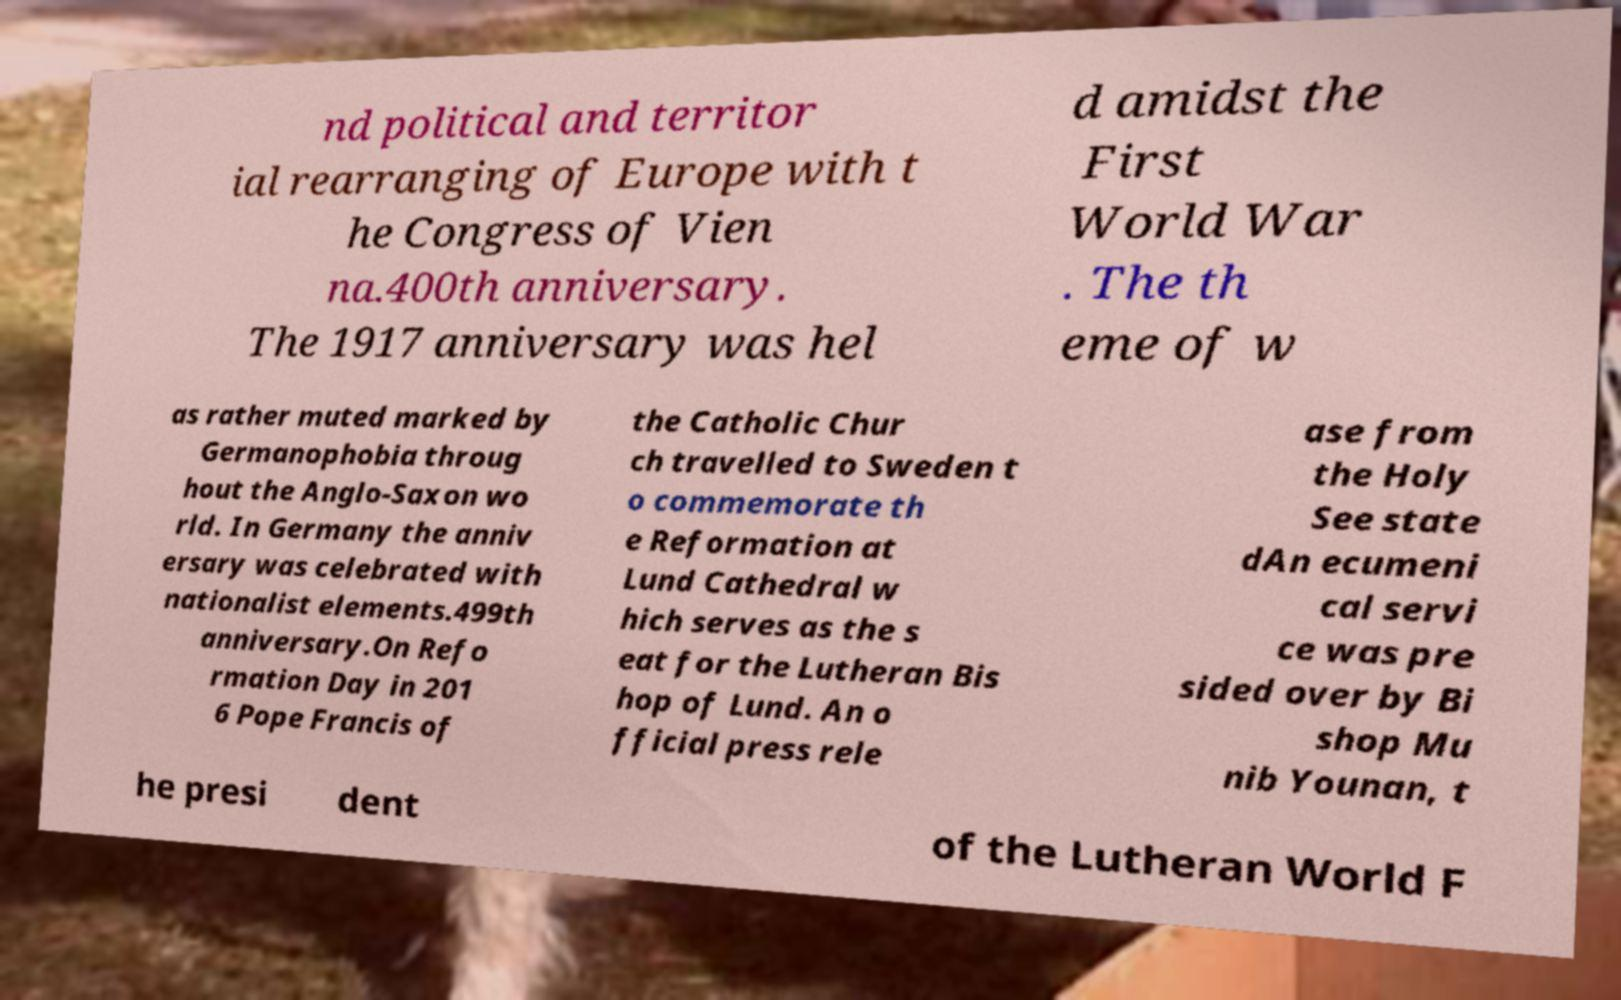Can you read and provide the text displayed in the image?This photo seems to have some interesting text. Can you extract and type it out for me? nd political and territor ial rearranging of Europe with t he Congress of Vien na.400th anniversary. The 1917 anniversary was hel d amidst the First World War . The th eme of w as rather muted marked by Germanophobia throug hout the Anglo-Saxon wo rld. In Germany the anniv ersary was celebrated with nationalist elements.499th anniversary.On Refo rmation Day in 201 6 Pope Francis of the Catholic Chur ch travelled to Sweden t o commemorate th e Reformation at Lund Cathedral w hich serves as the s eat for the Lutheran Bis hop of Lund. An o fficial press rele ase from the Holy See state dAn ecumeni cal servi ce was pre sided over by Bi shop Mu nib Younan, t he presi dent of the Lutheran World F 